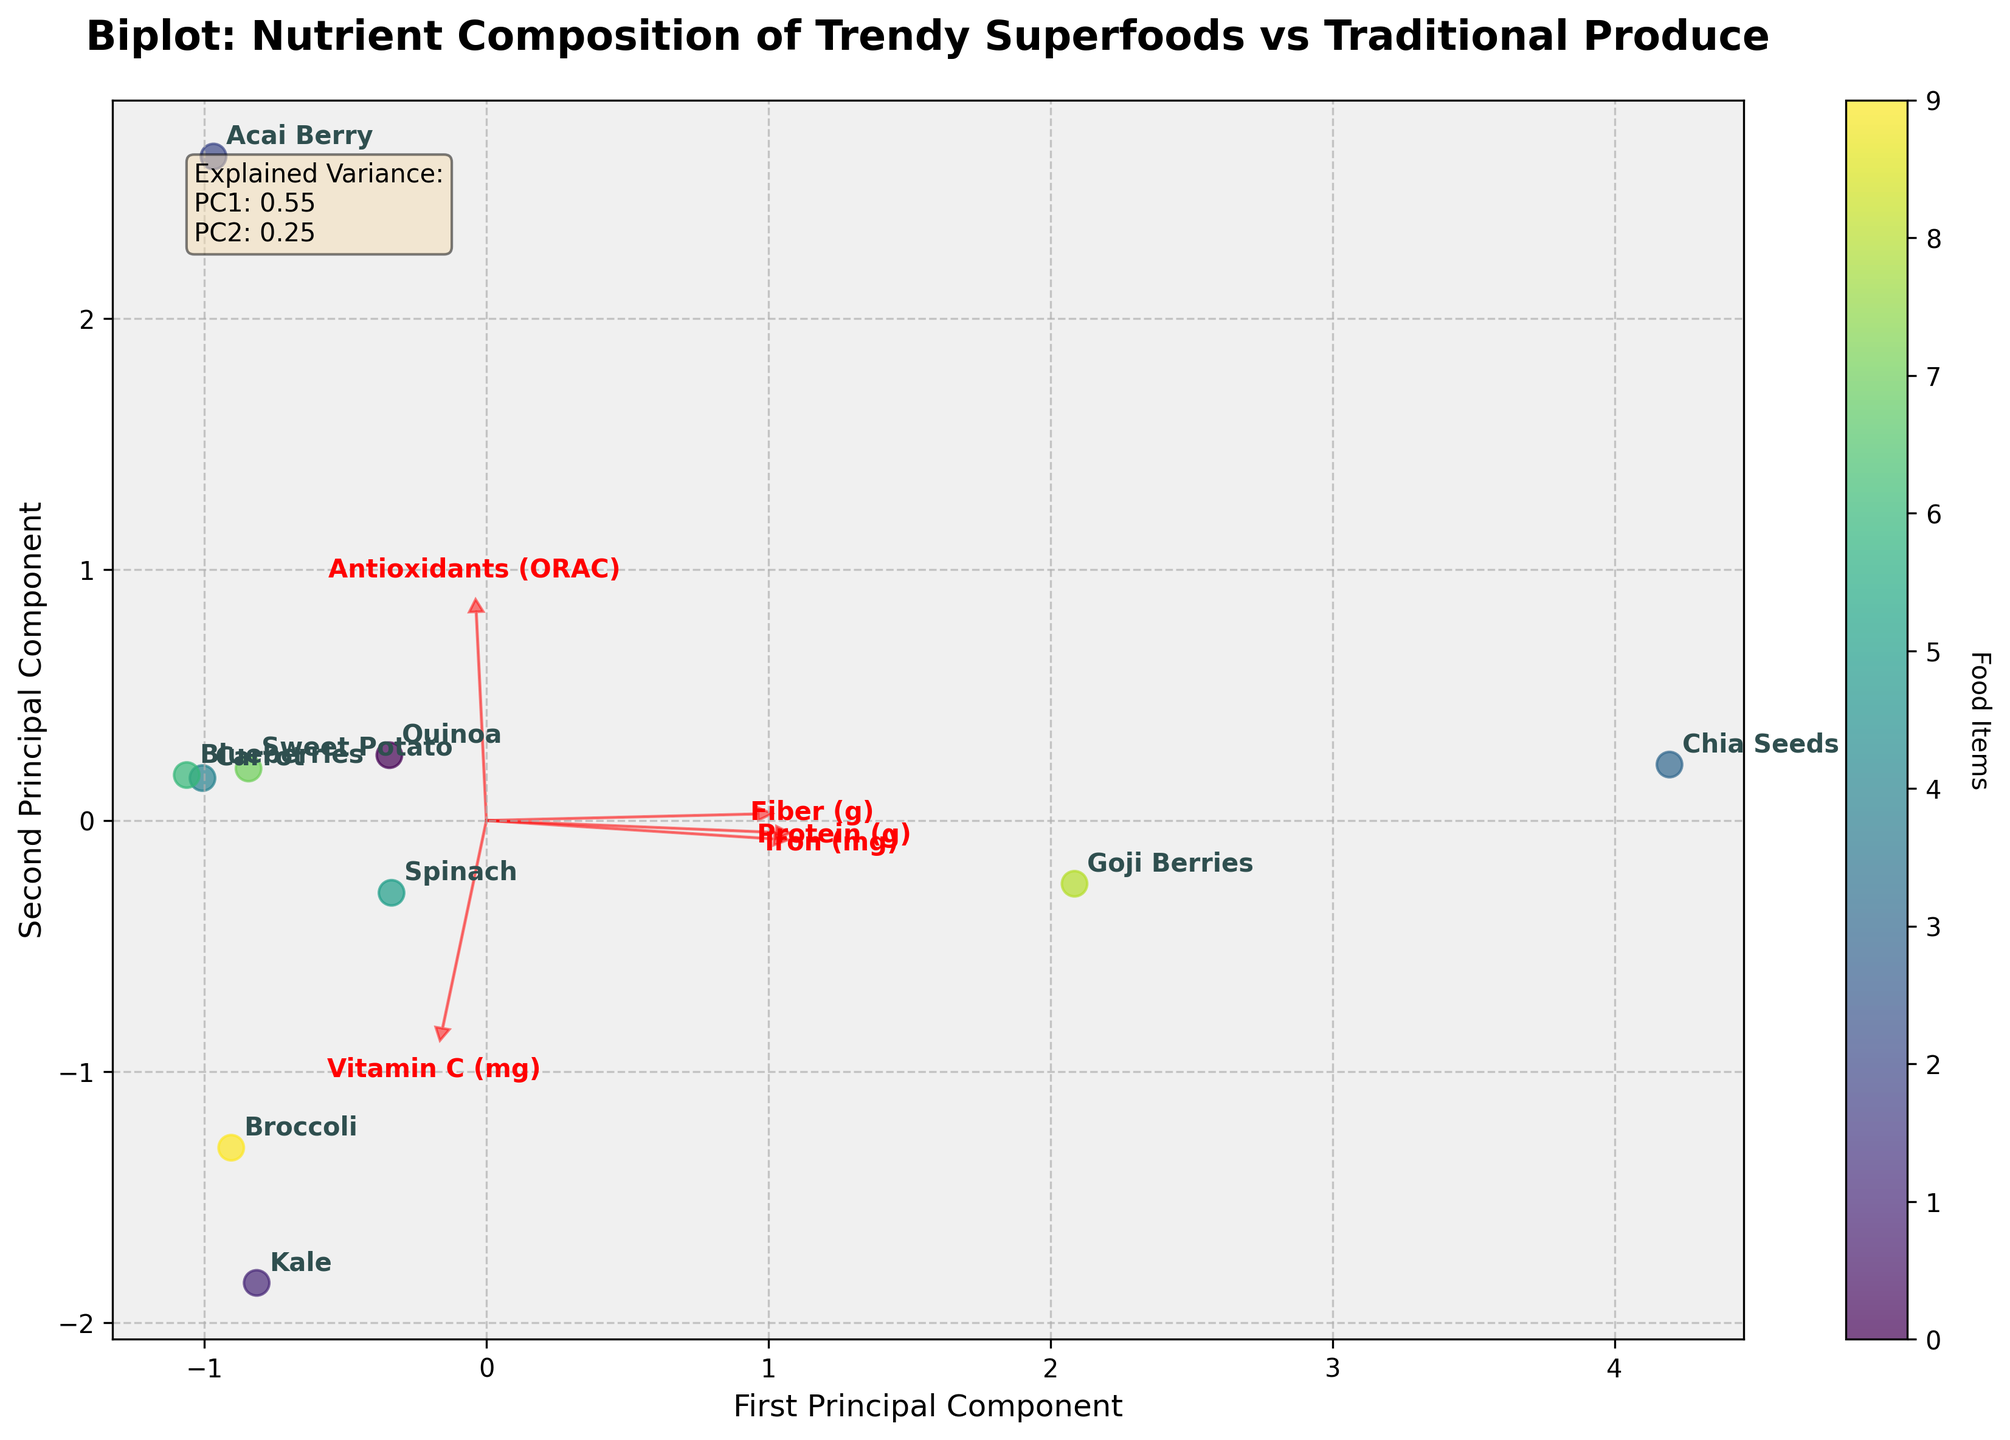What is the title of the plot? The title is positioned at the top of the plot and is usually in a larger, bold font. By reading the title directly, we get the main theme of the visualization.
Answer: "Biplot: Nutrient Composition of Trendy Superfoods vs Traditional Produce" What do the axes represent? The axis labels provide this information. The x-axis represents the 'First Principal Component', and the y-axis represents the 'Second Principal Component'.
Answer: 'First Principal Component' and 'Second Principal Component' Which food item has the highest value on the first principal component? The highest value on the first principal component (x-axis) can be identified by finding the point farthest to the right. The corresponding text annotation gives the food item's name.
Answer: Chia Seeds How are the features Protein (g) and Fiber (g) represented in the biplot? Features are represented by arrows. By locating the arrows labeled 'Protein (g)' and 'Fiber (g)', we can determine their directions and contribution to the principal components.
Answer: Red arrows pointing to specific directions Which food item has a higher second principal component, Acai Berry or Sweet Potato? By checking the y-axis values for both food items' annotations, we can compare their positions. The one higher on the y-axis has the higher second principal component value.
Answer: Acai Berry Which feature is most correlated with the first principal component? The feature whose arrow is longest and points most closely in the direction of the first principal component (x-axis) is most correlated with it. By examining the arrows, we can identify this feature.
Answer: Fiber (g) How do Goji Berries and Quinoa compare in terms of their nutrient composition based on the biplot? By examining their positions on the plot, we notice Goji Berries are higher on the second principal component, indicating differences in nutrient profile compared to Quinoa. Their separation distance indicates dissimilarity in composition.
Answer: Goji Berries are higher on the second principal component, highlighting different nutrient profiles Which food items are closer to the origin and what does it signify about their nutrient composition? The food items nearer to the origin (0,0) in the biplot suggests they have average nutrient values compared to the other items and principal components. Identifying these items involves looking for the annotations closest to the center.
Answer: Carrot and Spinach What does the color gradient in the scatter plot signify? The color gradient, often represented by a color bar, usually signifies a continuous variable across the data points. In this plot, it distinguishes the food items, but the exact color for each item is difficult to see without legend details.
Answer: Food items coding What information does the explained variance text box provide? The text box contains the proportion of variance explained by each principal component (PC1 and PC2). These values show how much of the overall variability in the data is captured by these components.
Answer: PC1: 0.67, PC2: 0.19 